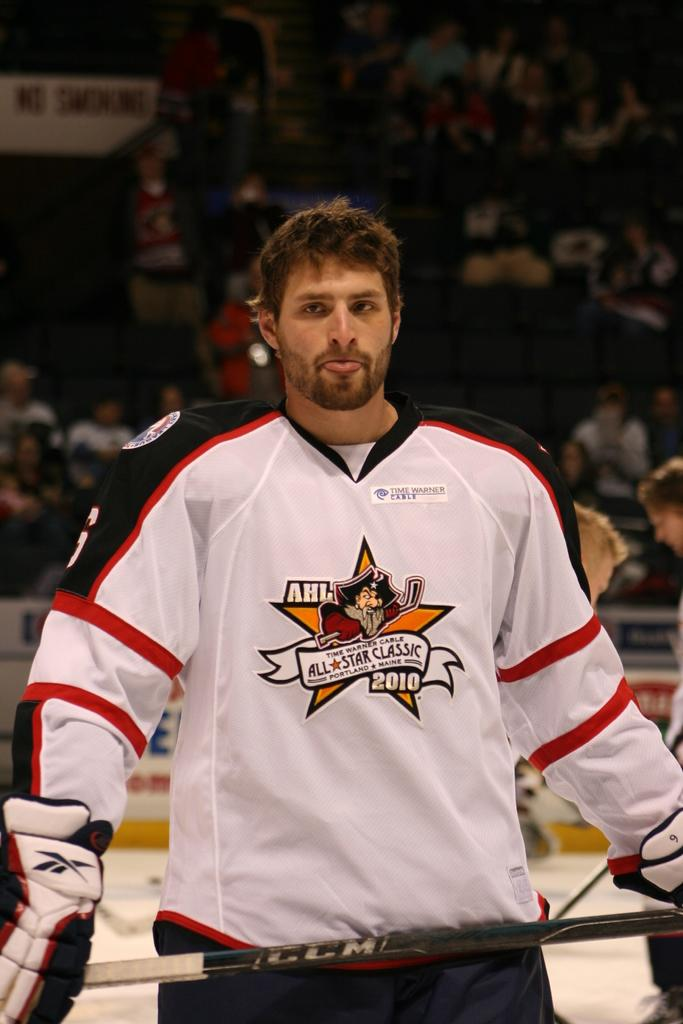<image>
Describe the image concisely. A hockey player wearing a jersey that says AHL All Star Classic 2010. 